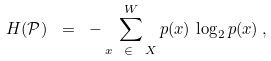Convert formula to latex. <formula><loc_0><loc_0><loc_500><loc_500>H ( { \mathcal { P } } ) \ = \ - \sum _ { x \ \, \in \ \, { X } } ^ { W } p ( x ) \, \log _ { 2 } p ( x ) \, , \\</formula> 